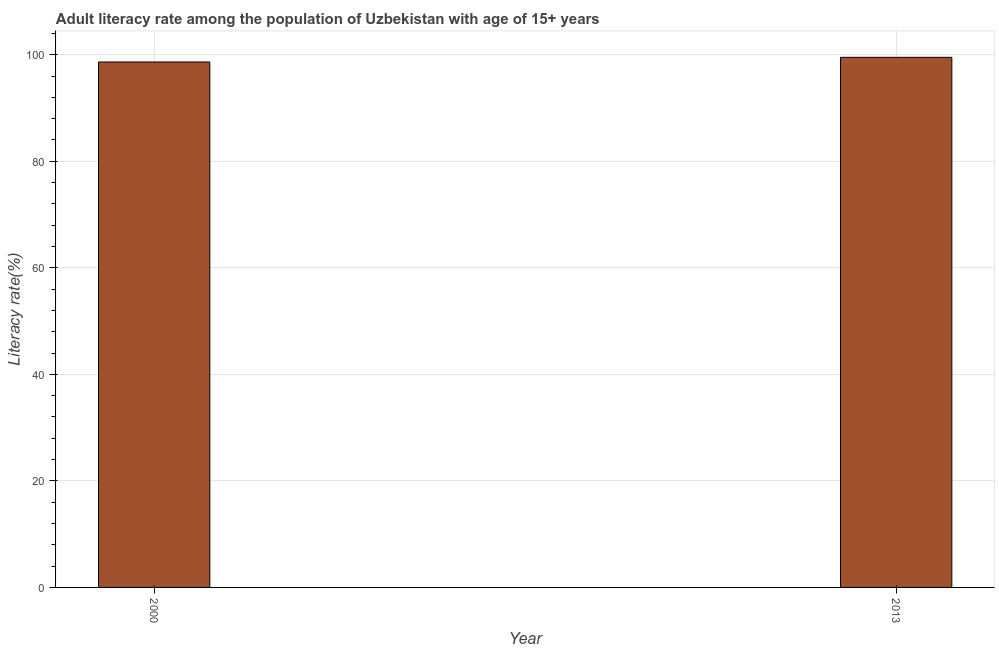What is the title of the graph?
Your response must be concise. Adult literacy rate among the population of Uzbekistan with age of 15+ years. What is the label or title of the Y-axis?
Your response must be concise. Literacy rate(%). What is the adult literacy rate in 2000?
Your answer should be very brief. 98.64. Across all years, what is the maximum adult literacy rate?
Your response must be concise. 99.52. Across all years, what is the minimum adult literacy rate?
Make the answer very short. 98.64. In which year was the adult literacy rate maximum?
Offer a very short reply. 2013. What is the sum of the adult literacy rate?
Your answer should be very brief. 198.16. What is the difference between the adult literacy rate in 2000 and 2013?
Ensure brevity in your answer.  -0.88. What is the average adult literacy rate per year?
Provide a succinct answer. 99.08. What is the median adult literacy rate?
Your answer should be very brief. 99.08. Is the adult literacy rate in 2000 less than that in 2013?
Ensure brevity in your answer.  Yes. How many bars are there?
Make the answer very short. 2. How many years are there in the graph?
Offer a very short reply. 2. What is the difference between two consecutive major ticks on the Y-axis?
Provide a succinct answer. 20. What is the Literacy rate(%) of 2000?
Your answer should be very brief. 98.64. What is the Literacy rate(%) in 2013?
Your response must be concise. 99.52. What is the difference between the Literacy rate(%) in 2000 and 2013?
Your response must be concise. -0.88. 